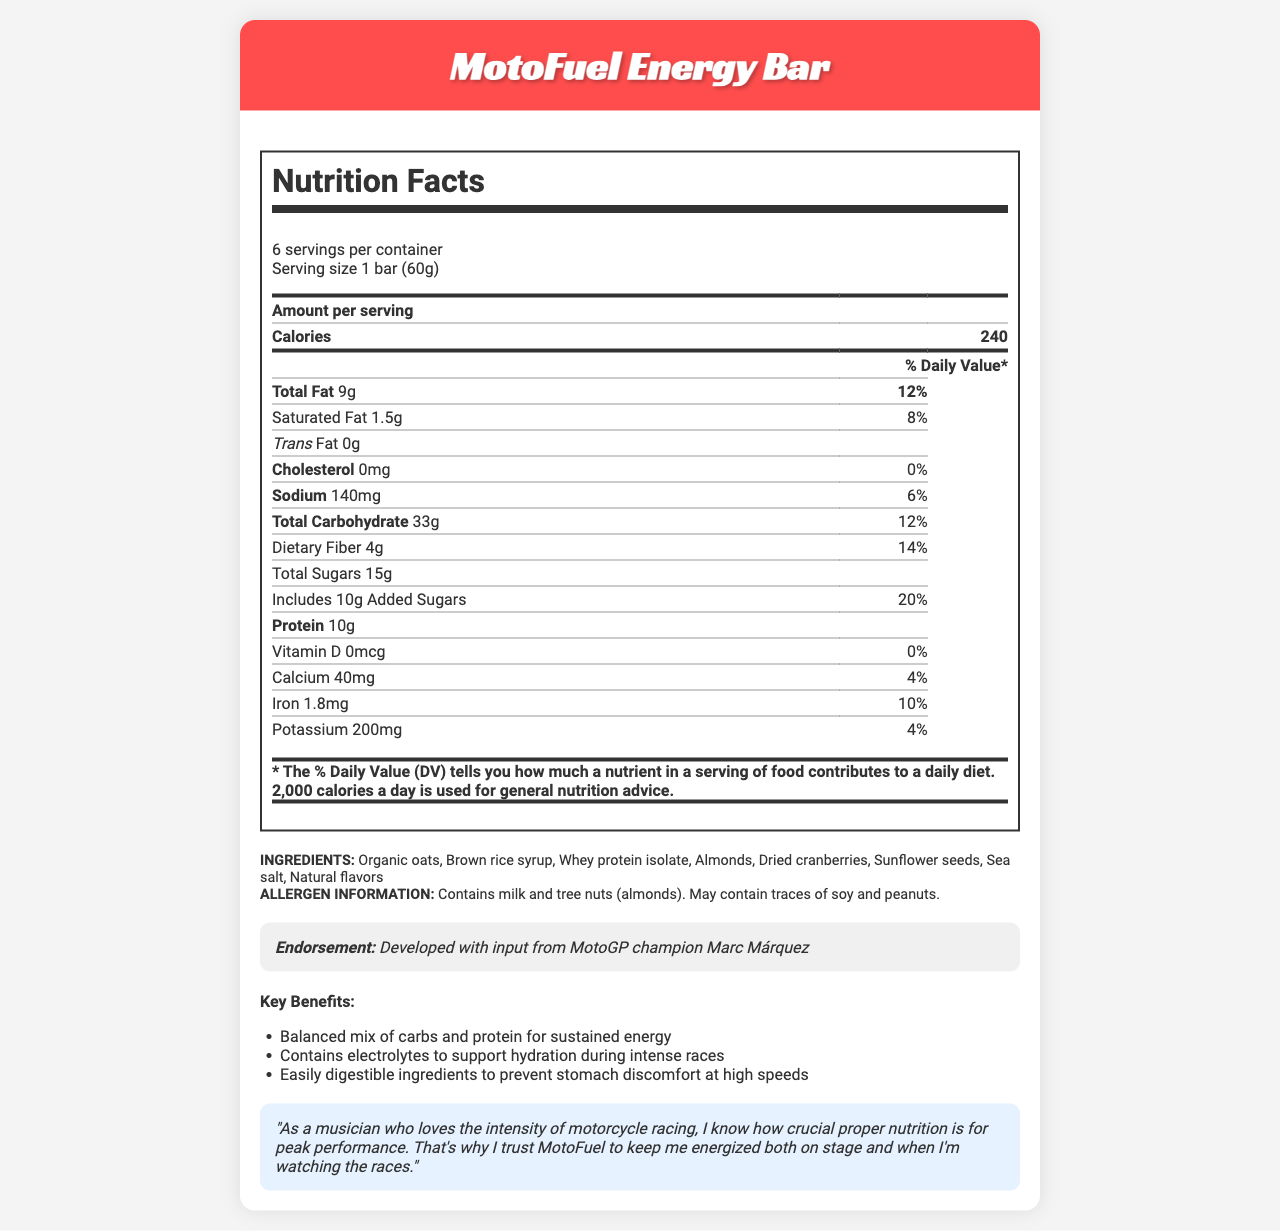what is the serving size for the MotoFuel Energy Bar? The serving size is clearly mentioned in the document as "1 bar (60g)."
Answer: 1 bar (60g) how many calories does one serving of the MotoFuel Energy Bar provide? The document states that one serving has 240 calories.
Answer: 240 what is the total amount of protein per serving of the MotoFuel Energy Bar? The document lists 10g of protein per serving.
Answer: 10g how much potassium is in one serving of the MotoFuel Energy Bar? The potassium content per serving is noted as 200mg in the document.
Answer: 200mg what are the main ingredients in the MotoFuel Energy Bar? The document specifies these ingredients are the main components of the energy bar.
Answer: Organic oats, Brown rice syrup, Whey protein isolate, Almonds, Dried cranberries, Sunflower seeds, Sea salt, Natural flavors what is the daily value percentage of dietary fiber per serving? The document shows that the daily value for dietary fiber is 14%.
Answer: 14% which racer endorsed the MotoFuel Energy Bar? The endorsement is clearly mentioned as coming from MotoGP champion Marc Márquez.
Answer: Marc Márquez How much added sugar is in each serving? 1. 5g 2. 10g 3. 15g 4. 20g The document states that each serving includes 10g of added sugars.
Answer: 2. 10g Which of the following items is NOT mentioned in the allergen information? A. Milk B. Soy C. Gluten D. Peanuts The document mentions milk, soy, and peanuts but does not mention gluten in the allergen information.
Answer: C. Gluten is the MotoFuel Energy Bar cholesterol-free? The document indicates that the cholesterol amount is 0mg, implying it is cholesterol-free.
Answer: Yes describe the key benefits of the MotoFuel Energy Bar. The document lists these three key benefits specifically under the "Key Benefits" section.
Answer: Balanced mix of carbs and protein for sustained energy, Contains electrolytes to support hydration during intense races, Easily digestible ingredients to prevent stomach discomfort at high speeds what is the main idea of the document? The document is designed to inform readers about the nutritional value and benefits of the MotoFuel Energy Bar, which is ideal for sustained energy and hydration during motorcycle races.
Answer: The document provides the nutrition facts, ingredients, allergen information, and endorsements for the MotoFuel Energy Bar, highlighting its suitability as a race-day snack endorsed by top motorcycle racers. How much calcium is present in one serving? The document states that each serving contains 40mg of calcium.
Answer: 40mg can you conclude the exact price of the MotoFuel Energy Bar from this document? The document does not provide any information regarding the price of the MotoFuel Energy Bar.
Answer: Not enough information 